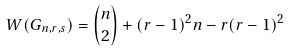Convert formula to latex. <formula><loc_0><loc_0><loc_500><loc_500>W ( G _ { n , r , s } ) = \binom { n } { 2 } + ( r - 1 ) ^ { 2 } n - r ( r - 1 ) ^ { 2 }</formula> 